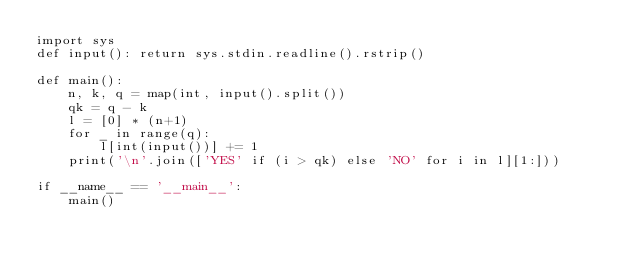Convert code to text. <code><loc_0><loc_0><loc_500><loc_500><_Python_>import sys
def input(): return sys.stdin.readline().rstrip()

def main():
    n, k, q = map(int, input().split())
    qk = q - k
    l = [0] * (n+1)
    for _ in range(q):
        l[int(input())] += 1
    print('\n'.join(['YES' if (i > qk) else 'NO' for i in l][1:]))

if __name__ == '__main__':
    main()
</code> 